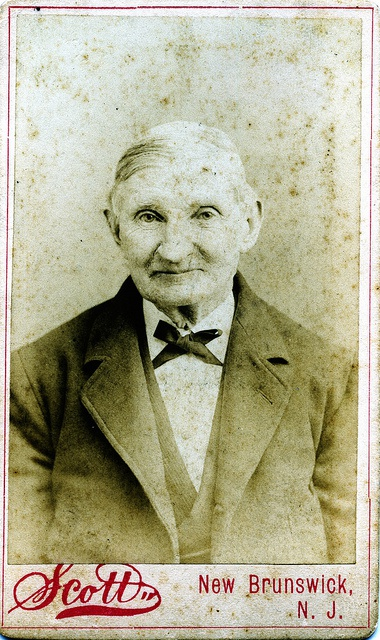Describe the objects in this image and their specific colors. I can see people in white, olive, black, and lightgray tones and tie in white, black, darkgreen, and olive tones in this image. 